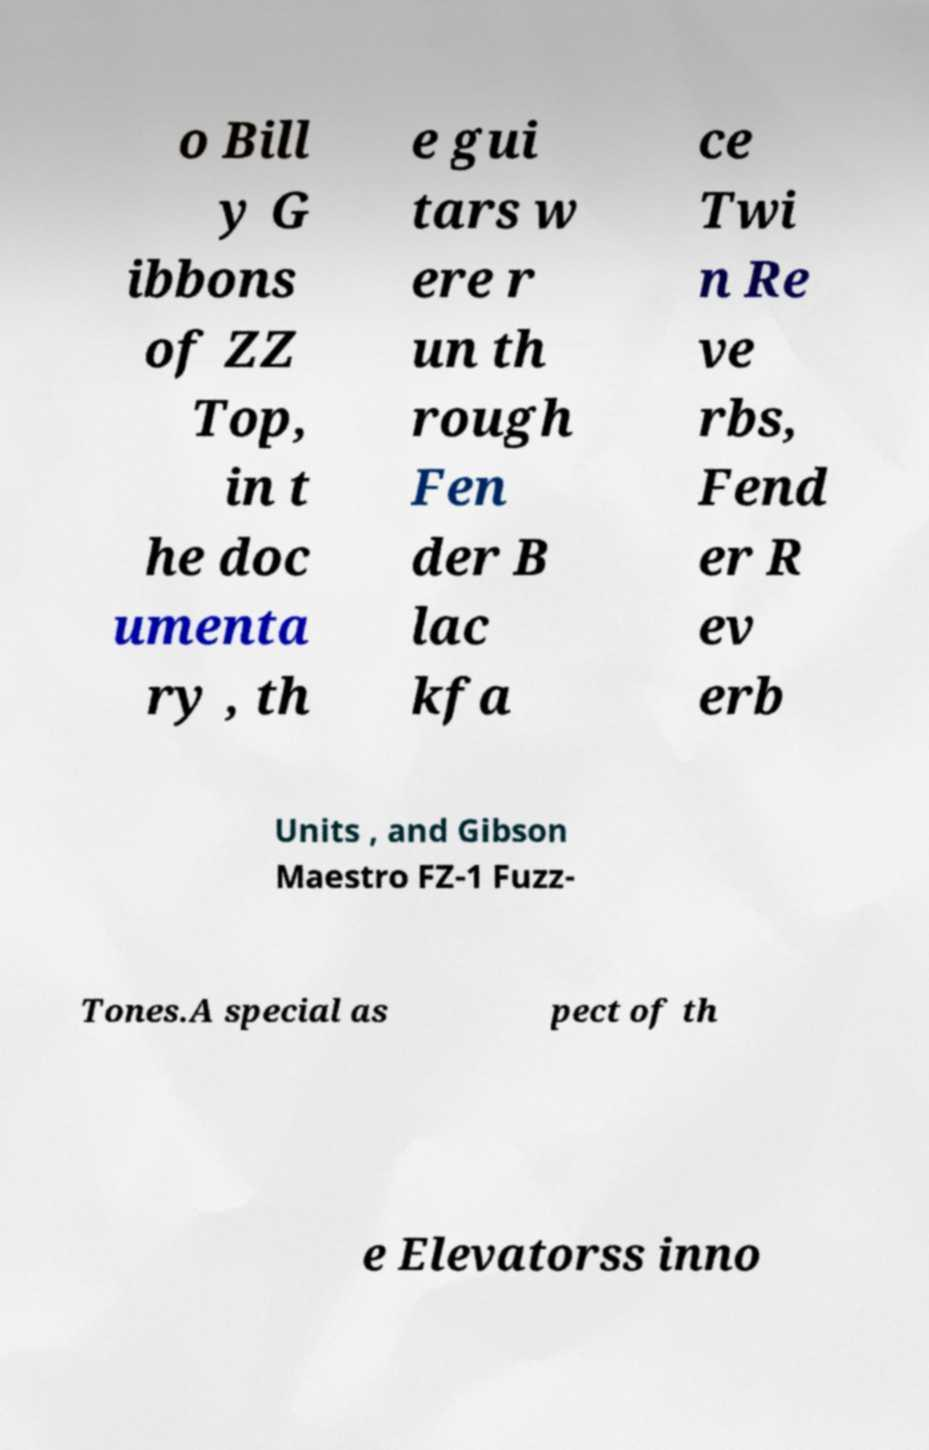Can you read and provide the text displayed in the image?This photo seems to have some interesting text. Can you extract and type it out for me? o Bill y G ibbons of ZZ Top, in t he doc umenta ry , th e gui tars w ere r un th rough Fen der B lac kfa ce Twi n Re ve rbs, Fend er R ev erb Units , and Gibson Maestro FZ-1 Fuzz- Tones.A special as pect of th e Elevatorss inno 